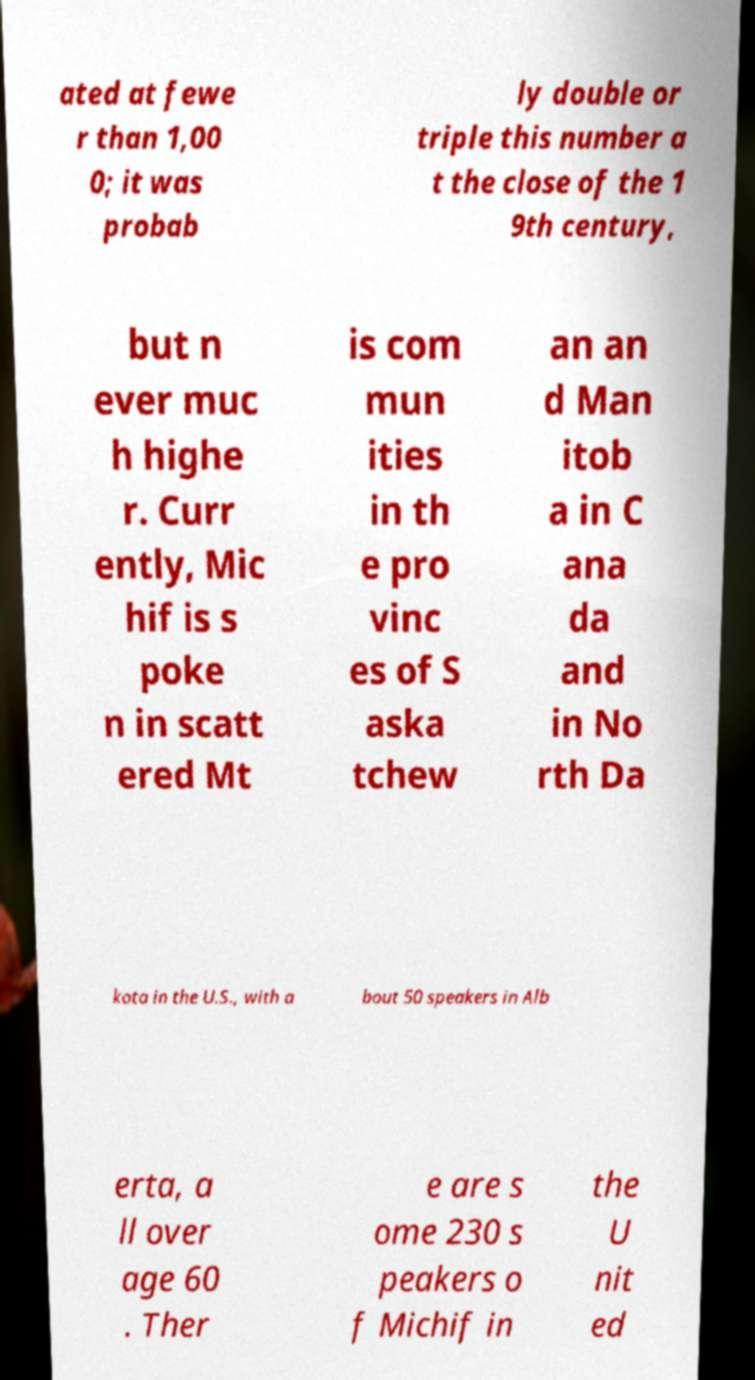For documentation purposes, I need the text within this image transcribed. Could you provide that? ated at fewe r than 1,00 0; it was probab ly double or triple this number a t the close of the 1 9th century, but n ever muc h highe r. Curr ently, Mic hif is s poke n in scatt ered Mt is com mun ities in th e pro vinc es of S aska tchew an an d Man itob a in C ana da and in No rth Da kota in the U.S., with a bout 50 speakers in Alb erta, a ll over age 60 . Ther e are s ome 230 s peakers o f Michif in the U nit ed 